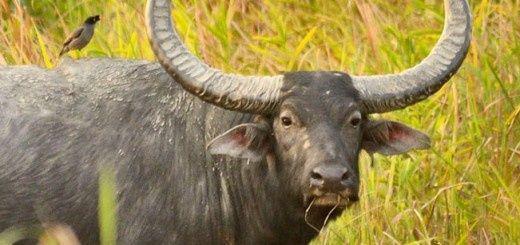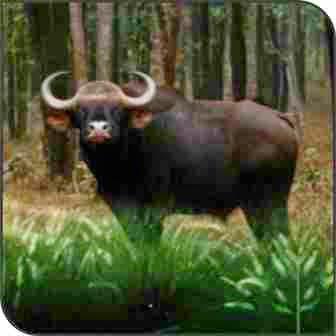The first image is the image on the left, the second image is the image on the right. Examine the images to the left and right. Is the description "There are two adult horned buffalo and no water." accurate? Answer yes or no. Yes. The first image is the image on the left, the second image is the image on the right. Evaluate the accuracy of this statement regarding the images: "In the image to the left, the ox is standing, surrounded by GREEN vegetation/grass.". Is it true? Answer yes or no. Yes. 